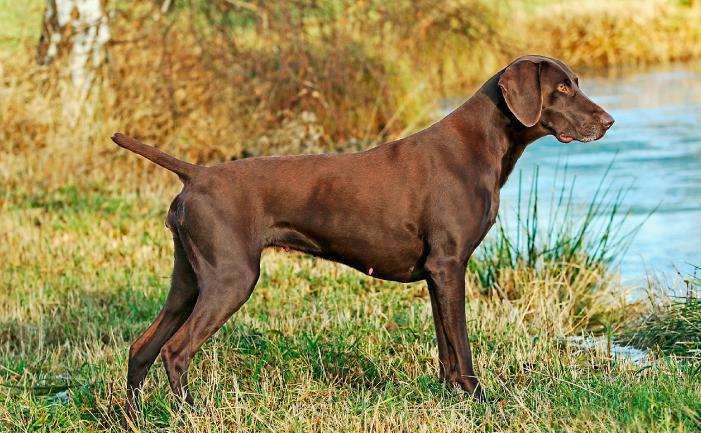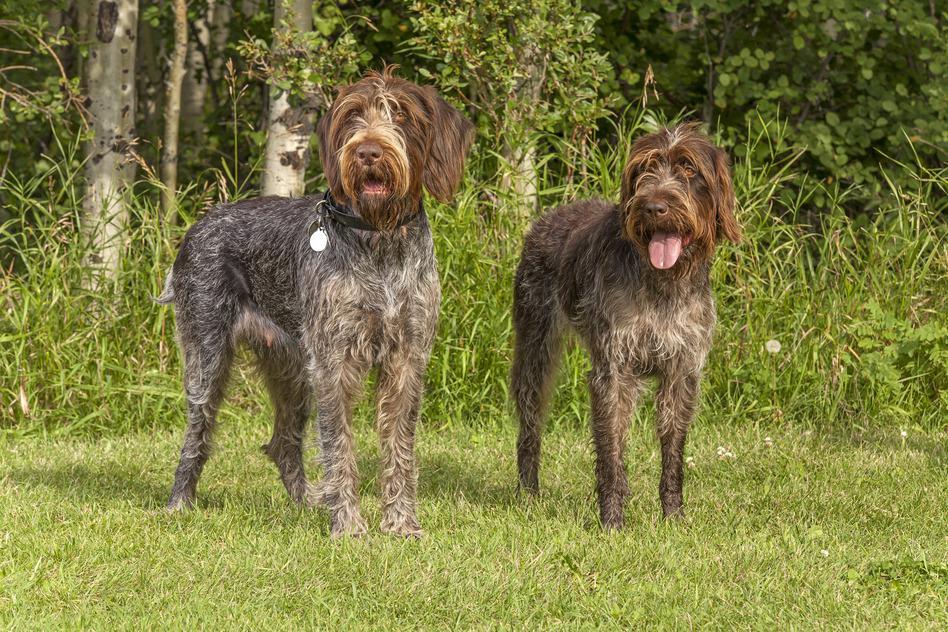The first image is the image on the left, the second image is the image on the right. Evaluate the accuracy of this statement regarding the images: "The left and right image contains the same number of dogs facing front right.". Is it true? Answer yes or no. No. The first image is the image on the left, the second image is the image on the right. Evaluate the accuracy of this statement regarding the images: "The left image contains one dog facing towards the right.". Is it true? Answer yes or no. Yes. 